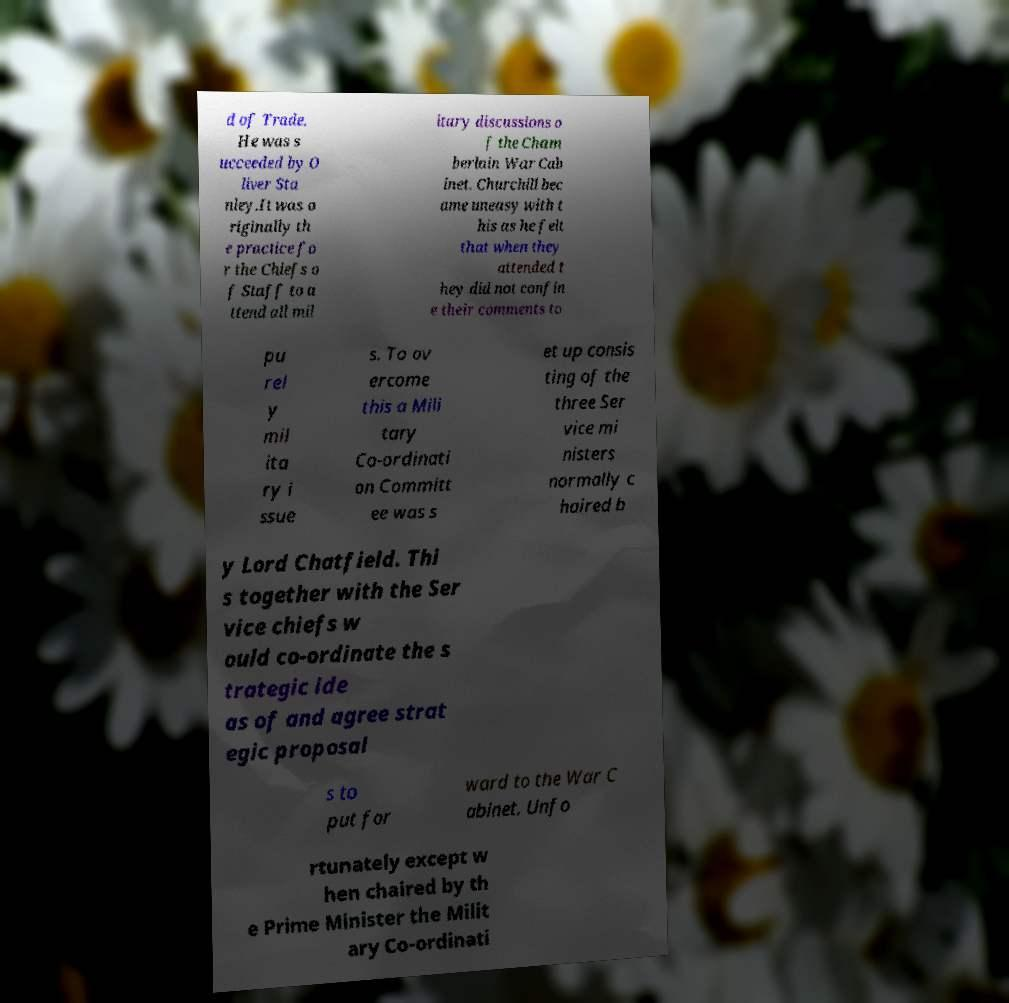Can you accurately transcribe the text from the provided image for me? d of Trade. He was s ucceeded by O liver Sta nley.It was o riginally th e practice fo r the Chiefs o f Staff to a ttend all mil itary discussions o f the Cham berlain War Cab inet. Churchill bec ame uneasy with t his as he felt that when they attended t hey did not confin e their comments to pu rel y mil ita ry i ssue s. To ov ercome this a Mili tary Co-ordinati on Committ ee was s et up consis ting of the three Ser vice mi nisters normally c haired b y Lord Chatfield. Thi s together with the Ser vice chiefs w ould co-ordinate the s trategic ide as of and agree strat egic proposal s to put for ward to the War C abinet. Unfo rtunately except w hen chaired by th e Prime Minister the Milit ary Co-ordinati 